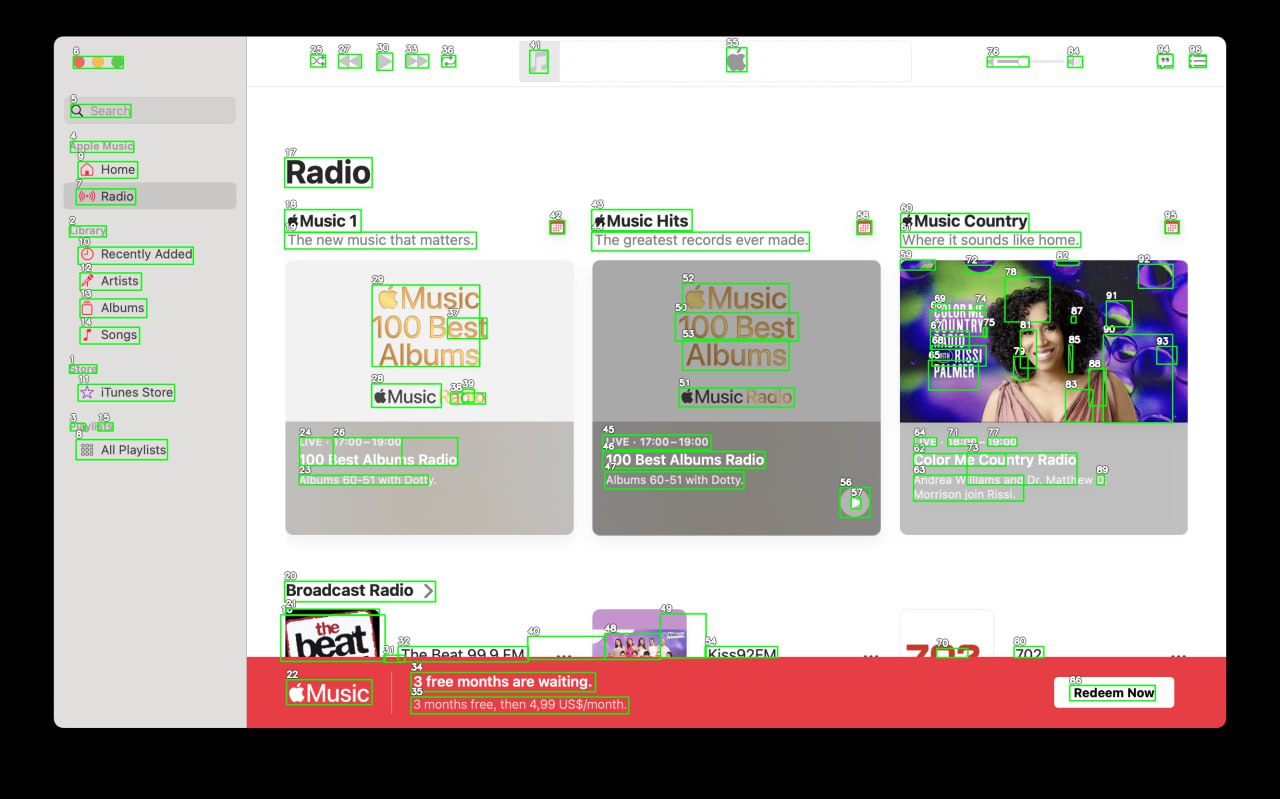Your task is to analyze the screenshot of the {app_name} on MacOS.  The screenshot is segmented with bounding boxes, each labeled with a number. The labels are always white numbers with a black outline. Number is always situated in the top left corner above the box. Segment the screen into logical parts, for example: top bar, main menu, ads bar etc. Provide as many categories as you can. Provide the output in JSON format connecting every category with list of numbers of the boxes that lie inside it.

For example,{
  "top_bar": [4, 7, 9, 13],
  "main_menu": [3, 8, 10, 15],
  "main_content": [6, 11, 12, 14, 16, 17],
  "ads_bar": [1, 2, 5]
}Note that you must find as many categories as you can, and can add subcategories inside of each of the categories. Based on the provided screenshot of the app on MacOS, I will categorize the segments into logical parts and provide the output in JSON format. The screenshot appears to show an application interface, likely a music or media-related app, segmented into various functional areas.

Here’s the JSON representation of the categories identified from the screenshot:

```json
{
  "sidebar": {
    "navigation_menu": [3, 5, 7, 9, 10, 12, 14, 15, 16, 17, 18],
    "search": [6]
  },
  "main_content": {
    "featured_radio_stations": [24, 26, 45, 46, 64, 70, 71, 77, 78, 79, 80, 81, 82, 83, 84, 85, 86, 87, 88, 89, 90, 91, 92, 93, 94],
    "music_categories": {
      "music_1": [19, 20, 21, 22, 23, 25, 27, 28, 29, 30, 31, 32, 33, 34, 35, 36, 37, 38, 39, 40, 41, 42, 43, 44, 47, 48, 49, 50, 51, 52, 53, 54, 55, 56, 57, 58, 59, 60, 61, 62, 63, 65, 66, 67, 68, 69, 72, 73, 74, 75, 76]
    }
  },
  "promotion_banner": [22]
}
```

**Explanation of Categories:**

- **Sidebar**: Contains elements for navigation through the app, including links to the homepage, radio, library sections, store, and playlists. It also includes a search bar.
  
- **Main Content**: The main area is divided into featured radio stations and music categories, showcasing different genres and spotlight features. This is where most of the user interaction with content occurs.

- **Promotion Banner**: A dedicated segment for promotional content, in this case, highlighting a subscription offer.

This JSON structure organizes the UI elements into logical groups that reflect the app’s layout and functionalities, helping developers or testers to understand the interface components better. 